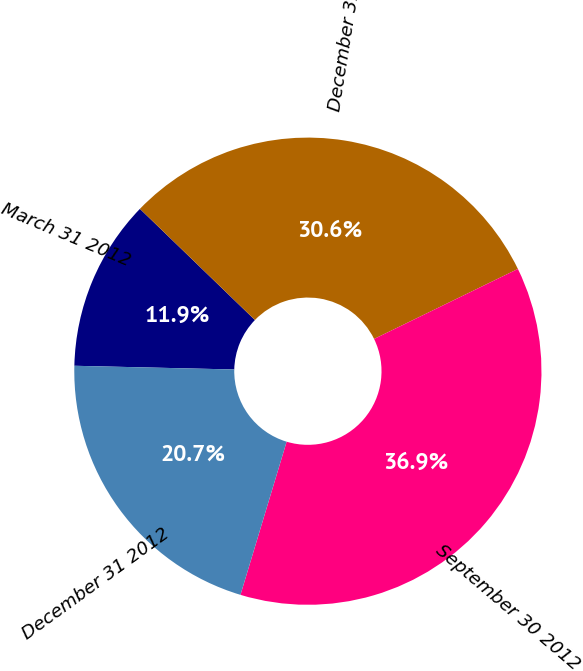<chart> <loc_0><loc_0><loc_500><loc_500><pie_chart><fcel>March 31 2012<fcel>December 31 2011<fcel>September 30 2012<fcel>December 31 2012<nl><fcel>11.86%<fcel>30.56%<fcel>36.87%<fcel>20.71%<nl></chart> 